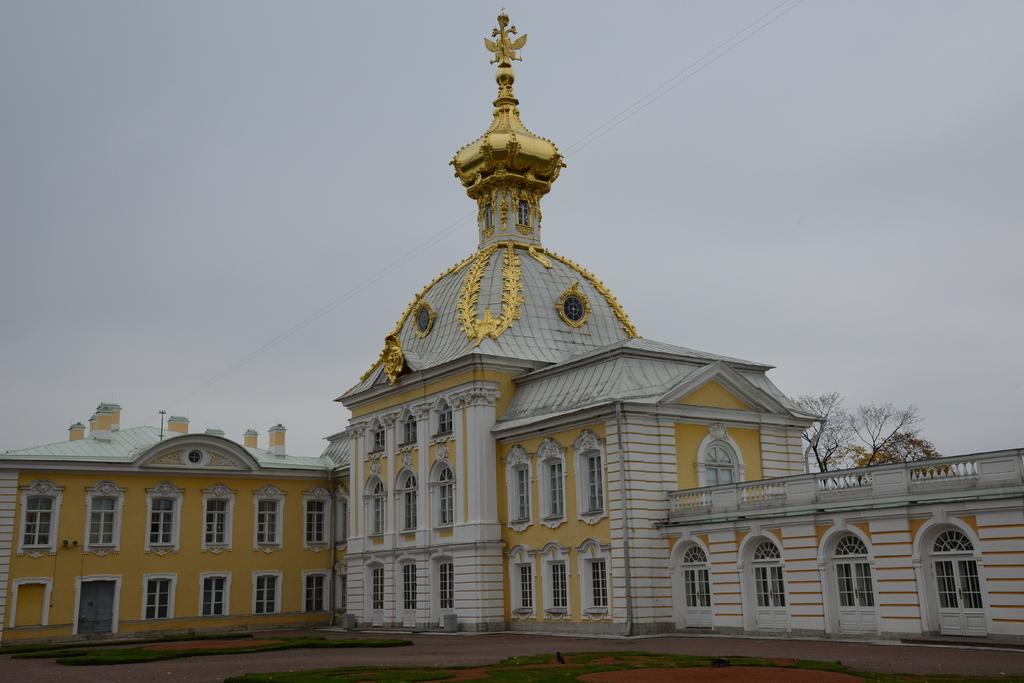What is the main structure visible in the foreground of the image? There is a building in the foreground of the image. What type of vegetation can be seen on the ground in the foreground? There is grass on the ground in the foreground. What can be seen in the background of the image? There are trees, cables, and the sky visible in the background. What type of bubble is floating near the building in the image? There is no bubble present in the image. What type of engine can be seen powering the trees in the background? There is no engine present in the image, and trees do not require engines to function. 